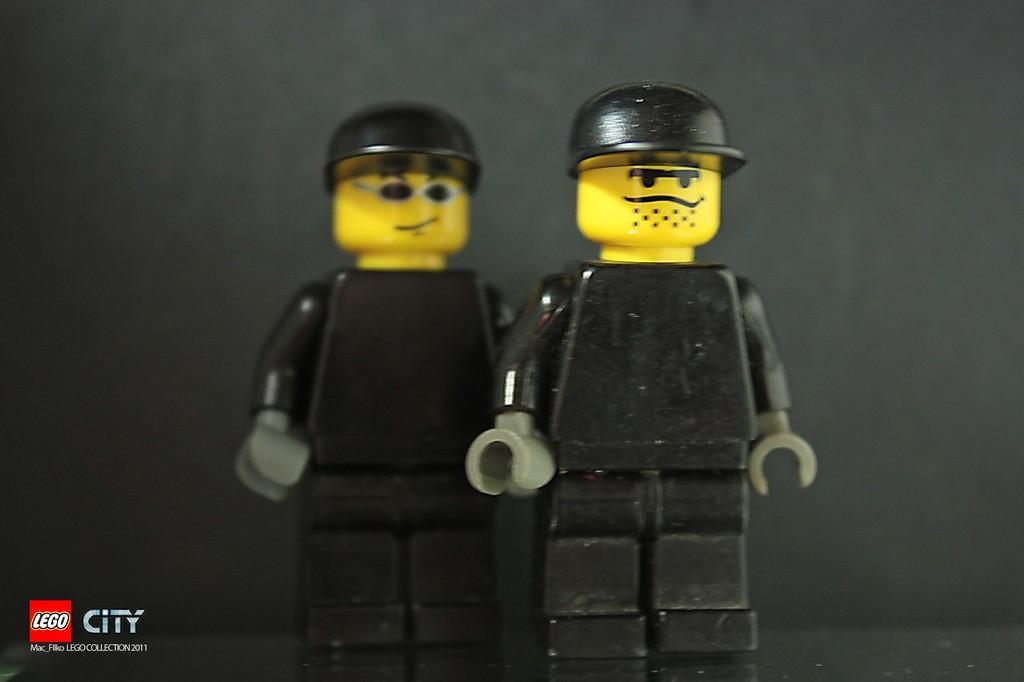Could you give a brief overview of what you see in this image? In this image we can see toys. In the left bottom corner there is watermark. In the background there is wall. 